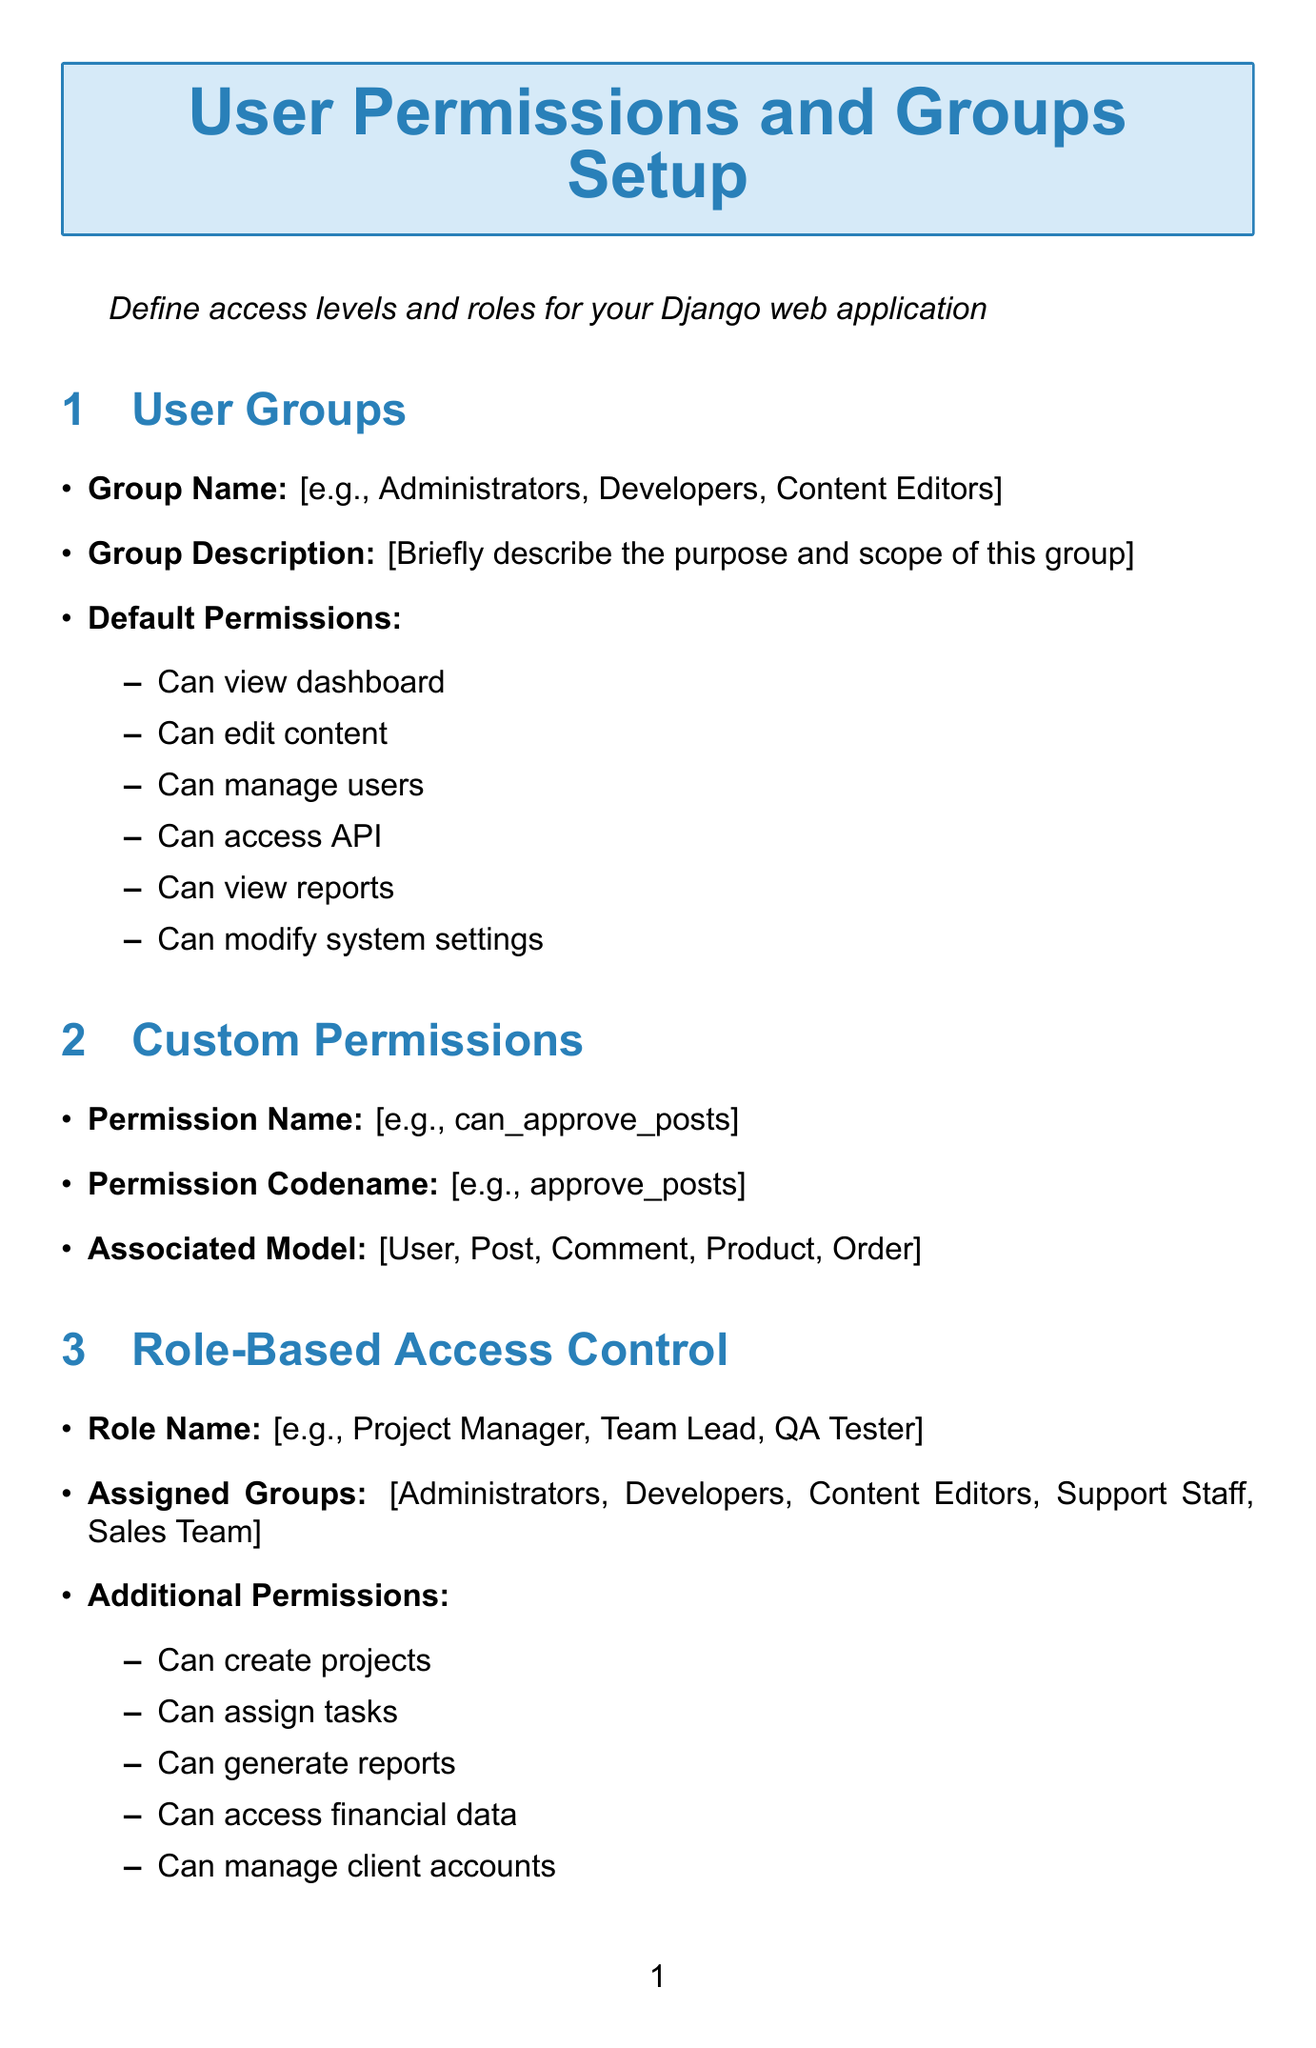What is the title of the document? The title is prominently displayed at the top of the document, indicating the purpose of the form.
Answer: User Permissions and Groups Setup What components are included in the User Groups section? The section lists the required fields for defining user groups, including their name and permissions.
Answer: Group Name, Group Description, Default Permissions What is the default session timeout in minutes? The document specifies the default timeout setting for user sessions.
Answer: 30 Which authentication method is enabled under Security Settings? The document mentions a security feature for staff and admin accounts to improve security.
Answer: Two-Factor Authentication How many options are available for the Password Policy? The document lists various policies to ensure strong password requirements.
Answer: 3 What is the range for the Maximum Login Attempts? The document specifies the minimum and maximum limits for login attempts to enhance security.
Answer: 3-10 What types of additional permissions can be assigned in Role-Based Access Control? The section suggests various operations that can be enhanced with additional permissions.
Answer: Can create projects, Can assign tasks, Can generate reports, Can access financial data, Can manage client accounts What is the type of the Group Name field? The document indicates the input type for the group name entry.
Answer: Text What is the purpose of the Enable Fine-Grained Access Control option? The document describes the functionality that allows for detailed permissions on individual objects.
Answer: Allow setting permissions for individual objects 